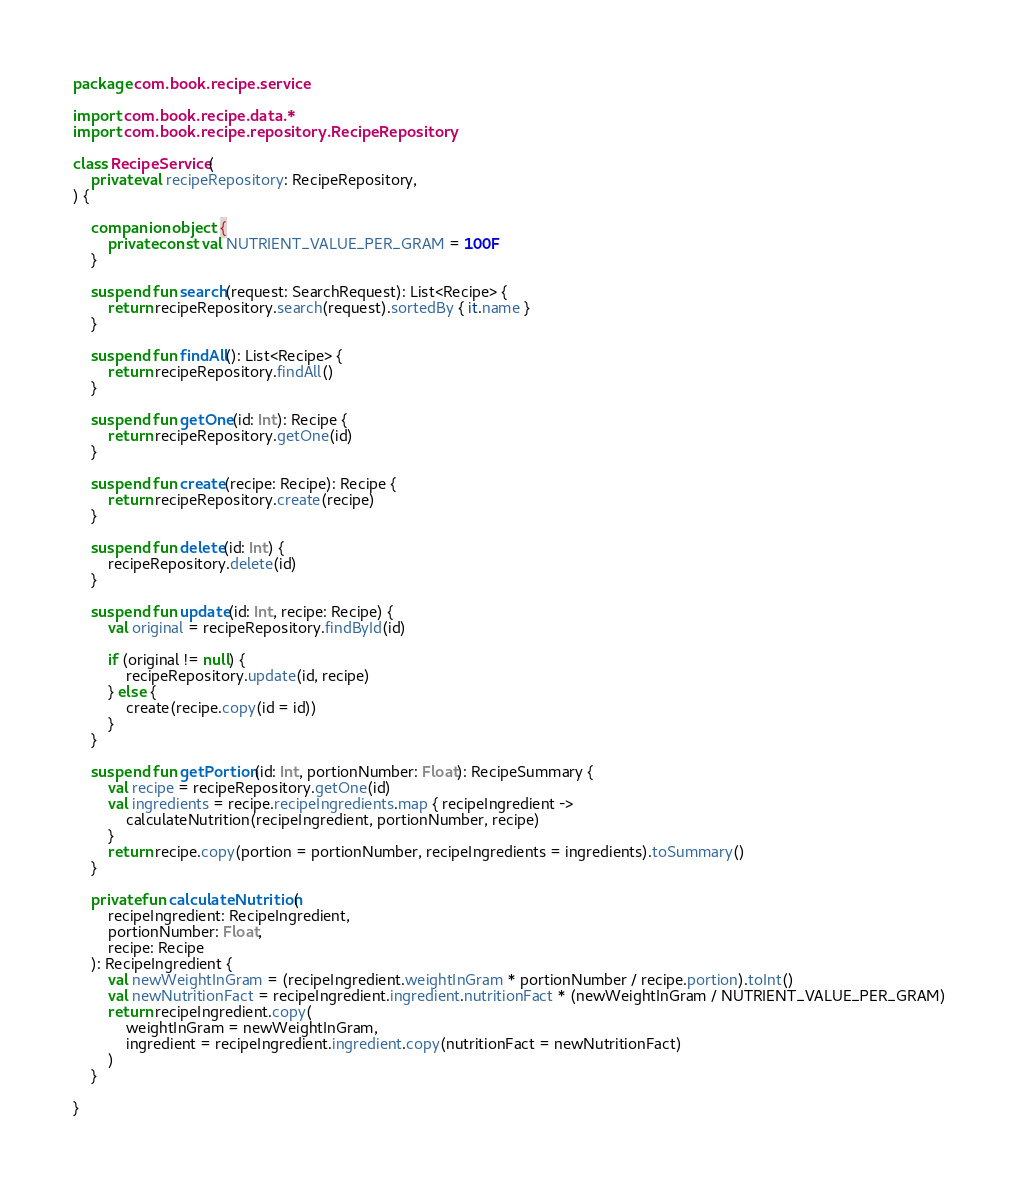Convert code to text. <code><loc_0><loc_0><loc_500><loc_500><_Kotlin_>package com.book.recipe.service

import com.book.recipe.data.*
import com.book.recipe.repository.RecipeRepository

class RecipeService(
    private val recipeRepository: RecipeRepository,
) {

    companion object {
        private const val NUTRIENT_VALUE_PER_GRAM = 100F
    }

    suspend fun search(request: SearchRequest): List<Recipe> {
        return recipeRepository.search(request).sortedBy { it.name }
    }

    suspend fun findAll(): List<Recipe> {
        return recipeRepository.findAll()
    }

    suspend fun getOne(id: Int): Recipe {
        return recipeRepository.getOne(id)
    }

    suspend fun create(recipe: Recipe): Recipe {
        return recipeRepository.create(recipe)
    }

    suspend fun delete(id: Int) {
        recipeRepository.delete(id)
    }

    suspend fun update(id: Int, recipe: Recipe) {
        val original = recipeRepository.findById(id)

        if (original != null) {
            recipeRepository.update(id, recipe)
        } else {
            create(recipe.copy(id = id))
        }
    }

    suspend fun getPortion(id: Int, portionNumber: Float): RecipeSummary {
        val recipe = recipeRepository.getOne(id)
        val ingredients = recipe.recipeIngredients.map { recipeIngredient ->
            calculateNutrition(recipeIngredient, portionNumber, recipe)
        }
        return recipe.copy(portion = portionNumber, recipeIngredients = ingredients).toSummary()
    }

    private fun calculateNutrition(
        recipeIngredient: RecipeIngredient,
        portionNumber: Float,
        recipe: Recipe
    ): RecipeIngredient {
        val newWeightInGram = (recipeIngredient.weightInGram * portionNumber / recipe.portion).toInt()
        val newNutritionFact = recipeIngredient.ingredient.nutritionFact * (newWeightInGram / NUTRIENT_VALUE_PER_GRAM)
        return recipeIngredient.copy(
            weightInGram = newWeightInGram,
            ingredient = recipeIngredient.ingredient.copy(nutritionFact = newNutritionFact)
        )
    }

}
</code> 